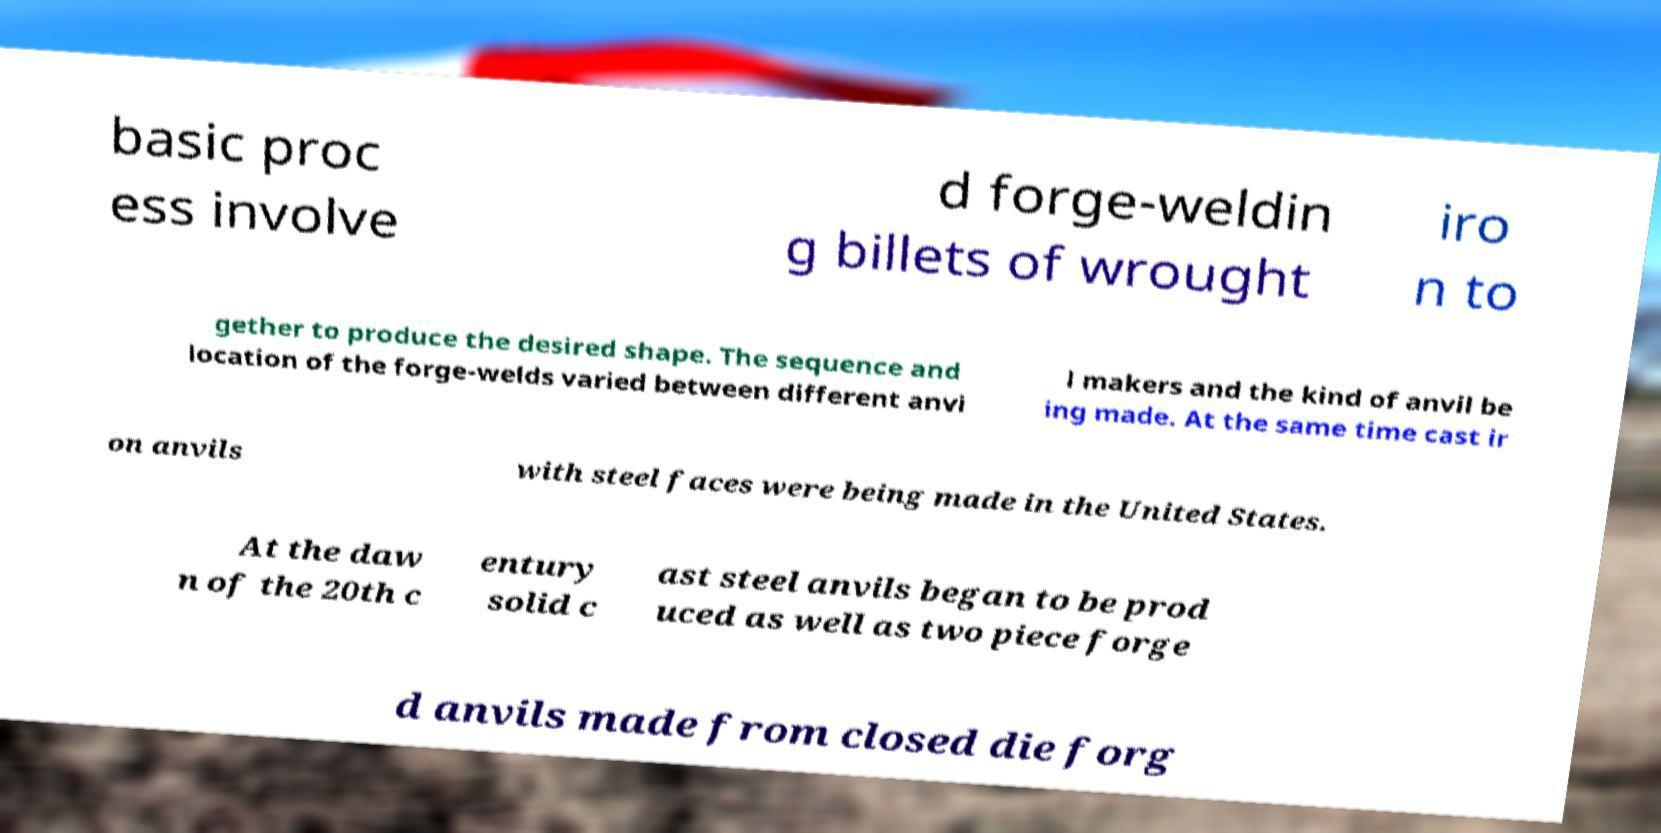Can you read and provide the text displayed in the image?This photo seems to have some interesting text. Can you extract and type it out for me? basic proc ess involve d forge-weldin g billets of wrought iro n to gether to produce the desired shape. The sequence and location of the forge-welds varied between different anvi l makers and the kind of anvil be ing made. At the same time cast ir on anvils with steel faces were being made in the United States. At the daw n of the 20th c entury solid c ast steel anvils began to be prod uced as well as two piece forge d anvils made from closed die forg 